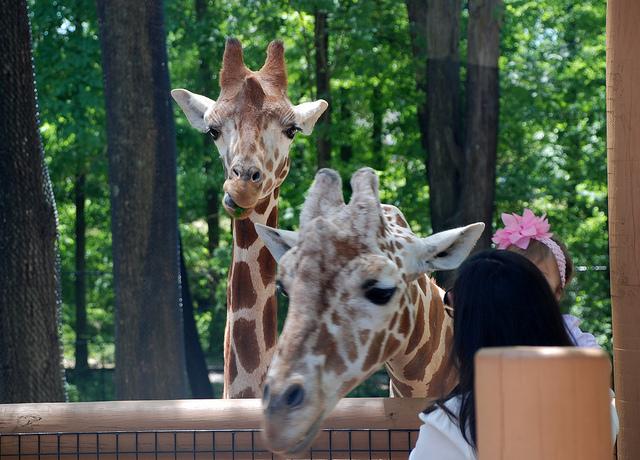Do these animals have sharp teeth?
Be succinct. No. How many giraffes are in the photo?
Give a very brief answer. 2. What is here besides the giraffes?
Quick response, please. People. 